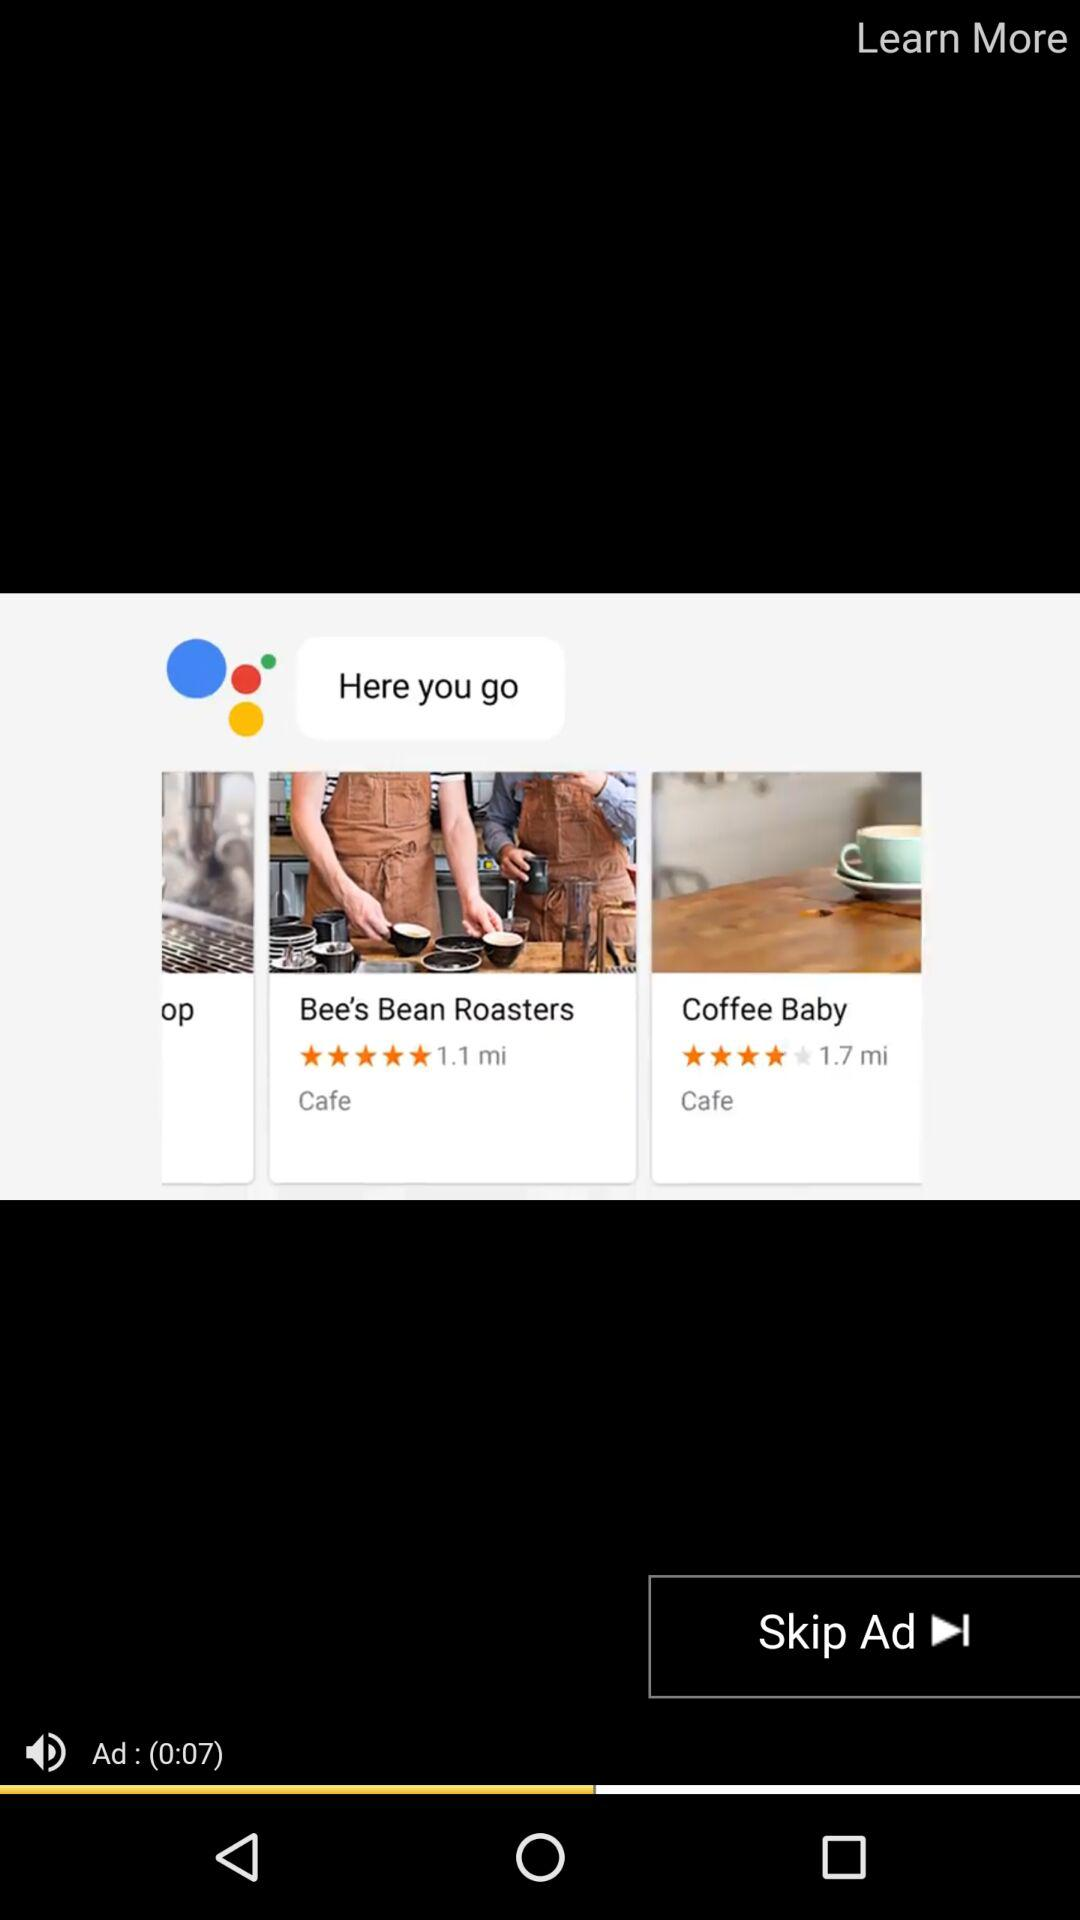Which coffee shop is closer to the user?
Answer the question using a single word or phrase. Bee's Bean Roasters 